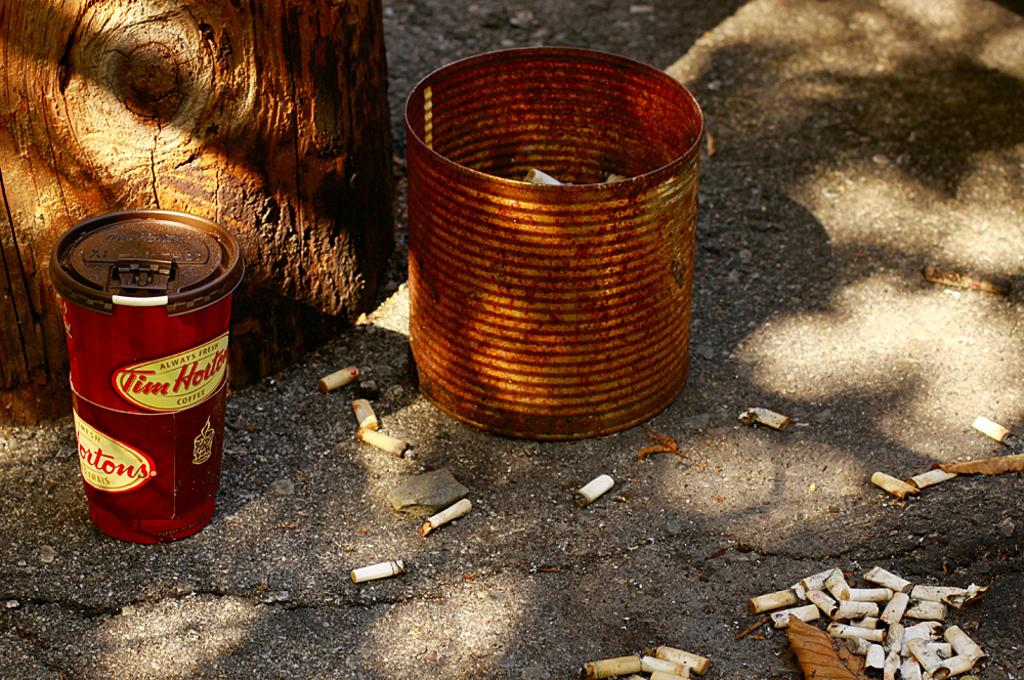<image>
Offer a succinct explanation of the picture presented. A LARGE RUSTY TIN CAN FILLED WITH BUTTS AND CAN OF TIM HORTONS 